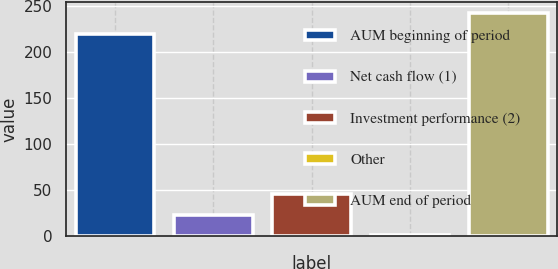Convert chart. <chart><loc_0><loc_0><loc_500><loc_500><bar_chart><fcel>AUM beginning of period<fcel>Net cash flow (1)<fcel>Investment performance (2)<fcel>Other<fcel>AUM end of period<nl><fcel>220.1<fcel>23.59<fcel>46.28<fcel>0.9<fcel>242.79<nl></chart> 